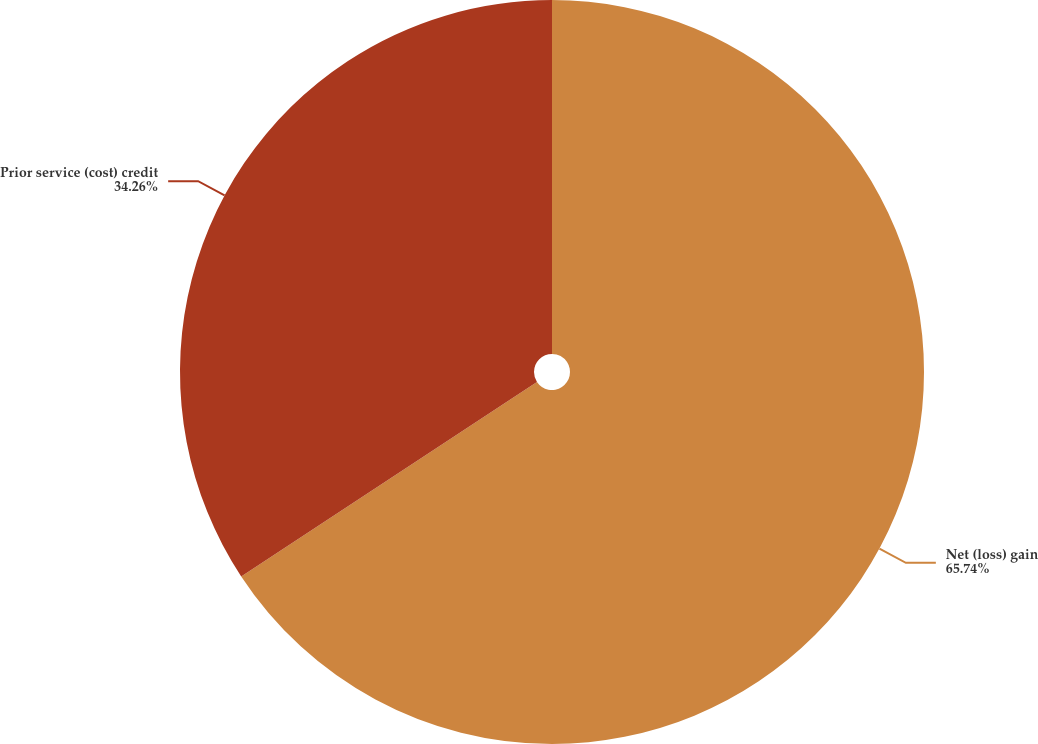<chart> <loc_0><loc_0><loc_500><loc_500><pie_chart><fcel>Net (loss) gain<fcel>Prior service (cost) credit<nl><fcel>65.74%<fcel>34.26%<nl></chart> 